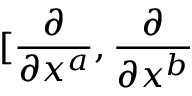<formula> <loc_0><loc_0><loc_500><loc_500>[ \frac { \partial } { \partial x ^ { a } } , \frac { \partial } { \partial x ^ { b } }</formula> 